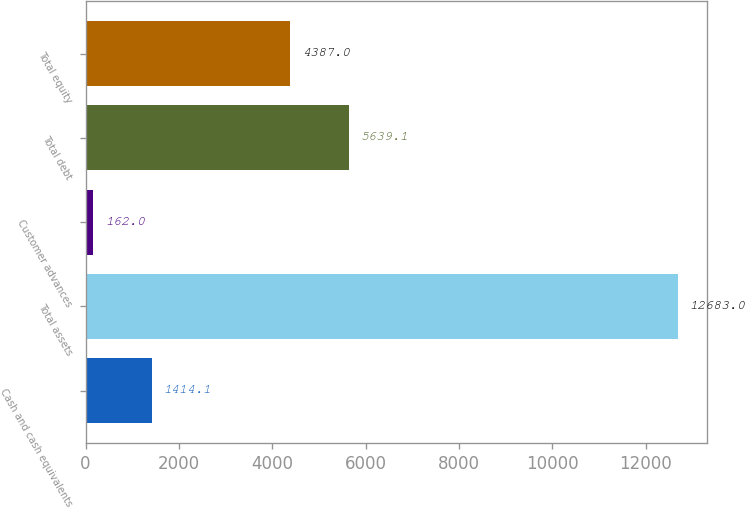Convert chart. <chart><loc_0><loc_0><loc_500><loc_500><bar_chart><fcel>Cash and cash equivalents<fcel>Total assets<fcel>Customer advances<fcel>Total debt<fcel>Total equity<nl><fcel>1414.1<fcel>12683<fcel>162<fcel>5639.1<fcel>4387<nl></chart> 